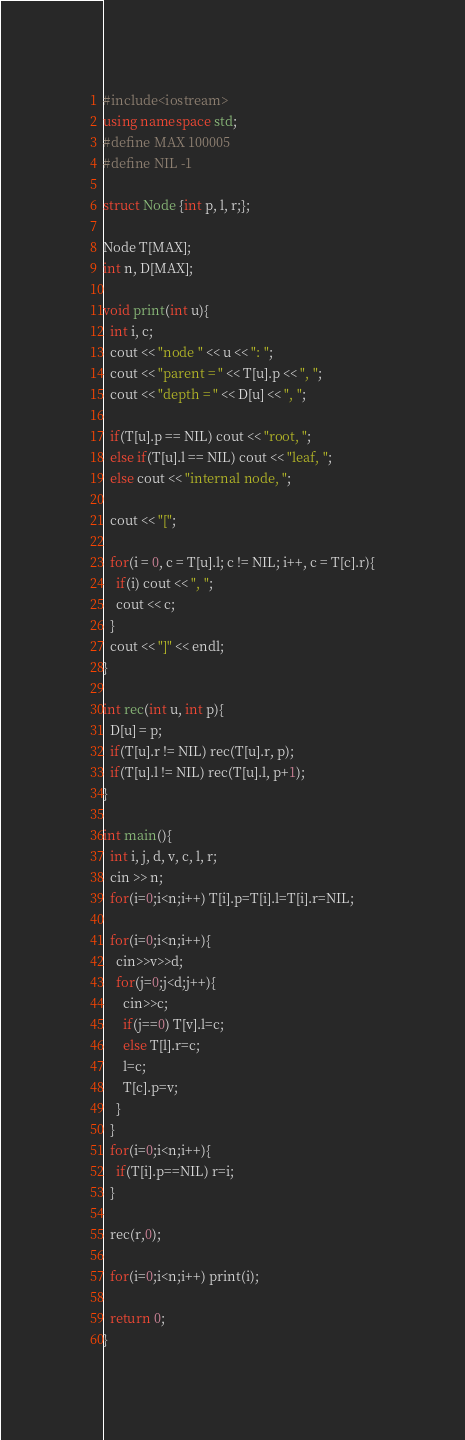Convert code to text. <code><loc_0><loc_0><loc_500><loc_500><_C++_>#include<iostream>
using namespace std;
#define MAX 100005
#define NIL -1

struct Node {int p, l, r;};

Node T[MAX];
int n, D[MAX];

void print(int u){
  int i, c;
  cout << "node " << u << ": ";
  cout << "parent = " << T[u].p << ", ";
  cout << "depth = " << D[u] << ", ";

  if(T[u].p == NIL) cout << "root, ";
  else if(T[u].l == NIL) cout << "leaf, ";
  else cout << "internal node, ";

  cout << "[";

  for(i = 0, c = T[u].l; c != NIL; i++, c = T[c].r){
    if(i) cout << ", ";
    cout << c;
  }
  cout << "]" << endl;
}

int rec(int u, int p){
  D[u] = p;
  if(T[u].r != NIL) rec(T[u].r, p);
  if(T[u].l != NIL) rec(T[u].l, p+1);
}

int main(){
  int i, j, d, v, c, l, r;
  cin >> n;
  for(i=0;i<n;i++) T[i].p=T[i].l=T[i].r=NIL;

  for(i=0;i<n;i++){
    cin>>v>>d;
    for(j=0;j<d;j++){
      cin>>c;
      if(j==0) T[v].l=c;
      else T[l].r=c;
      l=c;
      T[c].p=v;
    }
  }
  for(i=0;i<n;i++){
    if(T[i].p==NIL) r=i;
  }

  rec(r,0);

  for(i=0;i<n;i++) print(i);

  return 0;
}

</code> 